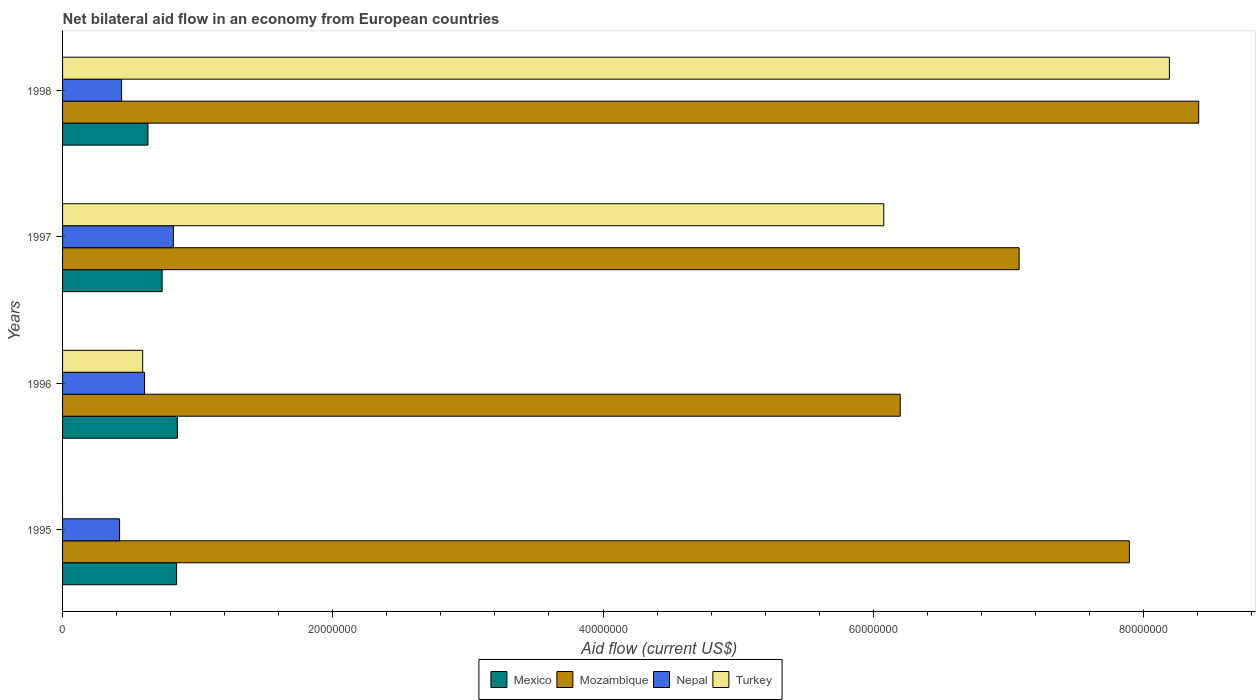Are the number of bars on each tick of the Y-axis equal?
Make the answer very short. No. How many bars are there on the 1st tick from the top?
Provide a succinct answer. 4. How many bars are there on the 4th tick from the bottom?
Make the answer very short. 4. What is the net bilateral aid flow in Mexico in 1995?
Offer a very short reply. 8.44e+06. Across all years, what is the maximum net bilateral aid flow in Mozambique?
Give a very brief answer. 8.41e+07. Across all years, what is the minimum net bilateral aid flow in Mozambique?
Your answer should be compact. 6.20e+07. In which year was the net bilateral aid flow in Mexico maximum?
Ensure brevity in your answer.  1996. What is the total net bilateral aid flow in Nepal in the graph?
Offer a very short reply. 2.29e+07. What is the difference between the net bilateral aid flow in Nepal in 1995 and that in 1997?
Provide a succinct answer. -3.98e+06. What is the average net bilateral aid flow in Turkey per year?
Ensure brevity in your answer.  3.72e+07. In the year 1997, what is the difference between the net bilateral aid flow in Mozambique and net bilateral aid flow in Mexico?
Ensure brevity in your answer.  6.34e+07. What is the ratio of the net bilateral aid flow in Mozambique in 1995 to that in 1998?
Your answer should be compact. 0.94. Is the net bilateral aid flow in Mexico in 1997 less than that in 1998?
Make the answer very short. No. Is the difference between the net bilateral aid flow in Mozambique in 1995 and 1997 greater than the difference between the net bilateral aid flow in Mexico in 1995 and 1997?
Give a very brief answer. Yes. What is the difference between the highest and the lowest net bilateral aid flow in Nepal?
Your response must be concise. 3.98e+06. In how many years, is the net bilateral aid flow in Nepal greater than the average net bilateral aid flow in Nepal taken over all years?
Offer a terse response. 2. Is it the case that in every year, the sum of the net bilateral aid flow in Mozambique and net bilateral aid flow in Nepal is greater than the net bilateral aid flow in Turkey?
Provide a succinct answer. Yes. Are all the bars in the graph horizontal?
Keep it short and to the point. Yes. How many years are there in the graph?
Offer a terse response. 4. What is the difference between two consecutive major ticks on the X-axis?
Give a very brief answer. 2.00e+07. Are the values on the major ticks of X-axis written in scientific E-notation?
Offer a very short reply. No. What is the title of the graph?
Offer a terse response. Net bilateral aid flow in an economy from European countries. Does "Australia" appear as one of the legend labels in the graph?
Make the answer very short. No. What is the label or title of the X-axis?
Give a very brief answer. Aid flow (current US$). What is the Aid flow (current US$) of Mexico in 1995?
Provide a succinct answer. 8.44e+06. What is the Aid flow (current US$) in Mozambique in 1995?
Your response must be concise. 7.90e+07. What is the Aid flow (current US$) in Nepal in 1995?
Offer a terse response. 4.22e+06. What is the Aid flow (current US$) in Mexico in 1996?
Your response must be concise. 8.50e+06. What is the Aid flow (current US$) of Mozambique in 1996?
Make the answer very short. 6.20e+07. What is the Aid flow (current US$) in Nepal in 1996?
Provide a short and direct response. 6.07e+06. What is the Aid flow (current US$) of Turkey in 1996?
Offer a terse response. 5.93e+06. What is the Aid flow (current US$) in Mexico in 1997?
Your answer should be compact. 7.37e+06. What is the Aid flow (current US$) of Mozambique in 1997?
Your answer should be very brief. 7.08e+07. What is the Aid flow (current US$) of Nepal in 1997?
Offer a terse response. 8.20e+06. What is the Aid flow (current US$) in Turkey in 1997?
Your response must be concise. 6.08e+07. What is the Aid flow (current US$) of Mexico in 1998?
Make the answer very short. 6.32e+06. What is the Aid flow (current US$) of Mozambique in 1998?
Your answer should be compact. 8.41e+07. What is the Aid flow (current US$) in Nepal in 1998?
Your answer should be compact. 4.37e+06. What is the Aid flow (current US$) in Turkey in 1998?
Provide a short and direct response. 8.19e+07. Across all years, what is the maximum Aid flow (current US$) of Mexico?
Offer a terse response. 8.50e+06. Across all years, what is the maximum Aid flow (current US$) in Mozambique?
Offer a terse response. 8.41e+07. Across all years, what is the maximum Aid flow (current US$) in Nepal?
Ensure brevity in your answer.  8.20e+06. Across all years, what is the maximum Aid flow (current US$) of Turkey?
Offer a terse response. 8.19e+07. Across all years, what is the minimum Aid flow (current US$) of Mexico?
Ensure brevity in your answer.  6.32e+06. Across all years, what is the minimum Aid flow (current US$) in Mozambique?
Your answer should be very brief. 6.20e+07. Across all years, what is the minimum Aid flow (current US$) of Nepal?
Offer a terse response. 4.22e+06. Across all years, what is the minimum Aid flow (current US$) of Turkey?
Your answer should be very brief. 0. What is the total Aid flow (current US$) of Mexico in the graph?
Provide a short and direct response. 3.06e+07. What is the total Aid flow (current US$) in Mozambique in the graph?
Offer a very short reply. 2.96e+08. What is the total Aid flow (current US$) in Nepal in the graph?
Ensure brevity in your answer.  2.29e+07. What is the total Aid flow (current US$) of Turkey in the graph?
Your answer should be very brief. 1.49e+08. What is the difference between the Aid flow (current US$) of Mexico in 1995 and that in 1996?
Provide a short and direct response. -6.00e+04. What is the difference between the Aid flow (current US$) in Mozambique in 1995 and that in 1996?
Your response must be concise. 1.70e+07. What is the difference between the Aid flow (current US$) of Nepal in 1995 and that in 1996?
Your response must be concise. -1.85e+06. What is the difference between the Aid flow (current US$) of Mexico in 1995 and that in 1997?
Your answer should be compact. 1.07e+06. What is the difference between the Aid flow (current US$) of Mozambique in 1995 and that in 1997?
Your response must be concise. 8.16e+06. What is the difference between the Aid flow (current US$) in Nepal in 1995 and that in 1997?
Your response must be concise. -3.98e+06. What is the difference between the Aid flow (current US$) of Mexico in 1995 and that in 1998?
Keep it short and to the point. 2.12e+06. What is the difference between the Aid flow (current US$) in Mozambique in 1995 and that in 1998?
Give a very brief answer. -5.13e+06. What is the difference between the Aid flow (current US$) of Nepal in 1995 and that in 1998?
Provide a short and direct response. -1.50e+05. What is the difference between the Aid flow (current US$) in Mexico in 1996 and that in 1997?
Offer a terse response. 1.13e+06. What is the difference between the Aid flow (current US$) of Mozambique in 1996 and that in 1997?
Make the answer very short. -8.80e+06. What is the difference between the Aid flow (current US$) in Nepal in 1996 and that in 1997?
Your answer should be compact. -2.13e+06. What is the difference between the Aid flow (current US$) in Turkey in 1996 and that in 1997?
Keep it short and to the point. -5.48e+07. What is the difference between the Aid flow (current US$) of Mexico in 1996 and that in 1998?
Your answer should be very brief. 2.18e+06. What is the difference between the Aid flow (current US$) in Mozambique in 1996 and that in 1998?
Your answer should be compact. -2.21e+07. What is the difference between the Aid flow (current US$) in Nepal in 1996 and that in 1998?
Ensure brevity in your answer.  1.70e+06. What is the difference between the Aid flow (current US$) of Turkey in 1996 and that in 1998?
Offer a very short reply. -7.60e+07. What is the difference between the Aid flow (current US$) in Mexico in 1997 and that in 1998?
Make the answer very short. 1.05e+06. What is the difference between the Aid flow (current US$) of Mozambique in 1997 and that in 1998?
Make the answer very short. -1.33e+07. What is the difference between the Aid flow (current US$) in Nepal in 1997 and that in 1998?
Offer a very short reply. 3.83e+06. What is the difference between the Aid flow (current US$) in Turkey in 1997 and that in 1998?
Provide a succinct answer. -2.11e+07. What is the difference between the Aid flow (current US$) of Mexico in 1995 and the Aid flow (current US$) of Mozambique in 1996?
Make the answer very short. -5.36e+07. What is the difference between the Aid flow (current US$) of Mexico in 1995 and the Aid flow (current US$) of Nepal in 1996?
Offer a terse response. 2.37e+06. What is the difference between the Aid flow (current US$) of Mexico in 1995 and the Aid flow (current US$) of Turkey in 1996?
Your answer should be compact. 2.51e+06. What is the difference between the Aid flow (current US$) of Mozambique in 1995 and the Aid flow (current US$) of Nepal in 1996?
Provide a succinct answer. 7.29e+07. What is the difference between the Aid flow (current US$) in Mozambique in 1995 and the Aid flow (current US$) in Turkey in 1996?
Ensure brevity in your answer.  7.30e+07. What is the difference between the Aid flow (current US$) in Nepal in 1995 and the Aid flow (current US$) in Turkey in 1996?
Ensure brevity in your answer.  -1.71e+06. What is the difference between the Aid flow (current US$) of Mexico in 1995 and the Aid flow (current US$) of Mozambique in 1997?
Offer a terse response. -6.24e+07. What is the difference between the Aid flow (current US$) in Mexico in 1995 and the Aid flow (current US$) in Turkey in 1997?
Your answer should be very brief. -5.23e+07. What is the difference between the Aid flow (current US$) of Mozambique in 1995 and the Aid flow (current US$) of Nepal in 1997?
Keep it short and to the point. 7.08e+07. What is the difference between the Aid flow (current US$) in Mozambique in 1995 and the Aid flow (current US$) in Turkey in 1997?
Ensure brevity in your answer.  1.82e+07. What is the difference between the Aid flow (current US$) in Nepal in 1995 and the Aid flow (current US$) in Turkey in 1997?
Provide a succinct answer. -5.66e+07. What is the difference between the Aid flow (current US$) of Mexico in 1995 and the Aid flow (current US$) of Mozambique in 1998?
Offer a terse response. -7.56e+07. What is the difference between the Aid flow (current US$) in Mexico in 1995 and the Aid flow (current US$) in Nepal in 1998?
Offer a terse response. 4.07e+06. What is the difference between the Aid flow (current US$) in Mexico in 1995 and the Aid flow (current US$) in Turkey in 1998?
Keep it short and to the point. -7.35e+07. What is the difference between the Aid flow (current US$) of Mozambique in 1995 and the Aid flow (current US$) of Nepal in 1998?
Provide a short and direct response. 7.46e+07. What is the difference between the Aid flow (current US$) of Mozambique in 1995 and the Aid flow (current US$) of Turkey in 1998?
Offer a very short reply. -2.96e+06. What is the difference between the Aid flow (current US$) of Nepal in 1995 and the Aid flow (current US$) of Turkey in 1998?
Make the answer very short. -7.77e+07. What is the difference between the Aid flow (current US$) of Mexico in 1996 and the Aid flow (current US$) of Mozambique in 1997?
Your answer should be very brief. -6.23e+07. What is the difference between the Aid flow (current US$) of Mexico in 1996 and the Aid flow (current US$) of Nepal in 1997?
Provide a short and direct response. 3.00e+05. What is the difference between the Aid flow (current US$) in Mexico in 1996 and the Aid flow (current US$) in Turkey in 1997?
Provide a succinct answer. -5.23e+07. What is the difference between the Aid flow (current US$) of Mozambique in 1996 and the Aid flow (current US$) of Nepal in 1997?
Offer a very short reply. 5.38e+07. What is the difference between the Aid flow (current US$) of Mozambique in 1996 and the Aid flow (current US$) of Turkey in 1997?
Give a very brief answer. 1.22e+06. What is the difference between the Aid flow (current US$) of Nepal in 1996 and the Aid flow (current US$) of Turkey in 1997?
Offer a very short reply. -5.47e+07. What is the difference between the Aid flow (current US$) in Mexico in 1996 and the Aid flow (current US$) in Mozambique in 1998?
Provide a succinct answer. -7.56e+07. What is the difference between the Aid flow (current US$) in Mexico in 1996 and the Aid flow (current US$) in Nepal in 1998?
Offer a terse response. 4.13e+06. What is the difference between the Aid flow (current US$) in Mexico in 1996 and the Aid flow (current US$) in Turkey in 1998?
Your response must be concise. -7.34e+07. What is the difference between the Aid flow (current US$) in Mozambique in 1996 and the Aid flow (current US$) in Nepal in 1998?
Keep it short and to the point. 5.76e+07. What is the difference between the Aid flow (current US$) of Mozambique in 1996 and the Aid flow (current US$) of Turkey in 1998?
Give a very brief answer. -1.99e+07. What is the difference between the Aid flow (current US$) in Nepal in 1996 and the Aid flow (current US$) in Turkey in 1998?
Your response must be concise. -7.58e+07. What is the difference between the Aid flow (current US$) of Mexico in 1997 and the Aid flow (current US$) of Mozambique in 1998?
Offer a very short reply. -7.67e+07. What is the difference between the Aid flow (current US$) of Mexico in 1997 and the Aid flow (current US$) of Turkey in 1998?
Keep it short and to the point. -7.46e+07. What is the difference between the Aid flow (current US$) of Mozambique in 1997 and the Aid flow (current US$) of Nepal in 1998?
Give a very brief answer. 6.64e+07. What is the difference between the Aid flow (current US$) of Mozambique in 1997 and the Aid flow (current US$) of Turkey in 1998?
Make the answer very short. -1.11e+07. What is the difference between the Aid flow (current US$) of Nepal in 1997 and the Aid flow (current US$) of Turkey in 1998?
Provide a short and direct response. -7.37e+07. What is the average Aid flow (current US$) in Mexico per year?
Keep it short and to the point. 7.66e+06. What is the average Aid flow (current US$) of Mozambique per year?
Your response must be concise. 7.40e+07. What is the average Aid flow (current US$) in Nepal per year?
Ensure brevity in your answer.  5.72e+06. What is the average Aid flow (current US$) of Turkey per year?
Provide a short and direct response. 3.72e+07. In the year 1995, what is the difference between the Aid flow (current US$) of Mexico and Aid flow (current US$) of Mozambique?
Provide a succinct answer. -7.05e+07. In the year 1995, what is the difference between the Aid flow (current US$) of Mexico and Aid flow (current US$) of Nepal?
Your answer should be compact. 4.22e+06. In the year 1995, what is the difference between the Aid flow (current US$) in Mozambique and Aid flow (current US$) in Nepal?
Provide a short and direct response. 7.47e+07. In the year 1996, what is the difference between the Aid flow (current US$) of Mexico and Aid flow (current US$) of Mozambique?
Your answer should be compact. -5.35e+07. In the year 1996, what is the difference between the Aid flow (current US$) in Mexico and Aid flow (current US$) in Nepal?
Your answer should be very brief. 2.43e+06. In the year 1996, what is the difference between the Aid flow (current US$) in Mexico and Aid flow (current US$) in Turkey?
Keep it short and to the point. 2.57e+06. In the year 1996, what is the difference between the Aid flow (current US$) of Mozambique and Aid flow (current US$) of Nepal?
Provide a short and direct response. 5.59e+07. In the year 1996, what is the difference between the Aid flow (current US$) of Mozambique and Aid flow (current US$) of Turkey?
Offer a terse response. 5.61e+07. In the year 1996, what is the difference between the Aid flow (current US$) of Nepal and Aid flow (current US$) of Turkey?
Your response must be concise. 1.40e+05. In the year 1997, what is the difference between the Aid flow (current US$) in Mexico and Aid flow (current US$) in Mozambique?
Your response must be concise. -6.34e+07. In the year 1997, what is the difference between the Aid flow (current US$) in Mexico and Aid flow (current US$) in Nepal?
Provide a succinct answer. -8.30e+05. In the year 1997, what is the difference between the Aid flow (current US$) in Mexico and Aid flow (current US$) in Turkey?
Give a very brief answer. -5.34e+07. In the year 1997, what is the difference between the Aid flow (current US$) in Mozambique and Aid flow (current US$) in Nepal?
Offer a terse response. 6.26e+07. In the year 1997, what is the difference between the Aid flow (current US$) in Mozambique and Aid flow (current US$) in Turkey?
Give a very brief answer. 1.00e+07. In the year 1997, what is the difference between the Aid flow (current US$) of Nepal and Aid flow (current US$) of Turkey?
Your answer should be compact. -5.26e+07. In the year 1998, what is the difference between the Aid flow (current US$) in Mexico and Aid flow (current US$) in Mozambique?
Give a very brief answer. -7.78e+07. In the year 1998, what is the difference between the Aid flow (current US$) in Mexico and Aid flow (current US$) in Nepal?
Provide a short and direct response. 1.95e+06. In the year 1998, what is the difference between the Aid flow (current US$) in Mexico and Aid flow (current US$) in Turkey?
Make the answer very short. -7.56e+07. In the year 1998, what is the difference between the Aid flow (current US$) in Mozambique and Aid flow (current US$) in Nepal?
Ensure brevity in your answer.  7.97e+07. In the year 1998, what is the difference between the Aid flow (current US$) of Mozambique and Aid flow (current US$) of Turkey?
Offer a very short reply. 2.17e+06. In the year 1998, what is the difference between the Aid flow (current US$) of Nepal and Aid flow (current US$) of Turkey?
Your response must be concise. -7.76e+07. What is the ratio of the Aid flow (current US$) in Mexico in 1995 to that in 1996?
Your answer should be very brief. 0.99. What is the ratio of the Aid flow (current US$) of Mozambique in 1995 to that in 1996?
Provide a short and direct response. 1.27. What is the ratio of the Aid flow (current US$) of Nepal in 1995 to that in 1996?
Make the answer very short. 0.7. What is the ratio of the Aid flow (current US$) in Mexico in 1995 to that in 1997?
Make the answer very short. 1.15. What is the ratio of the Aid flow (current US$) in Mozambique in 1995 to that in 1997?
Make the answer very short. 1.12. What is the ratio of the Aid flow (current US$) of Nepal in 1995 to that in 1997?
Your answer should be compact. 0.51. What is the ratio of the Aid flow (current US$) in Mexico in 1995 to that in 1998?
Your response must be concise. 1.34. What is the ratio of the Aid flow (current US$) of Mozambique in 1995 to that in 1998?
Your answer should be compact. 0.94. What is the ratio of the Aid flow (current US$) of Nepal in 1995 to that in 1998?
Make the answer very short. 0.97. What is the ratio of the Aid flow (current US$) in Mexico in 1996 to that in 1997?
Make the answer very short. 1.15. What is the ratio of the Aid flow (current US$) of Mozambique in 1996 to that in 1997?
Give a very brief answer. 0.88. What is the ratio of the Aid flow (current US$) in Nepal in 1996 to that in 1997?
Your answer should be compact. 0.74. What is the ratio of the Aid flow (current US$) in Turkey in 1996 to that in 1997?
Ensure brevity in your answer.  0.1. What is the ratio of the Aid flow (current US$) in Mexico in 1996 to that in 1998?
Your response must be concise. 1.34. What is the ratio of the Aid flow (current US$) in Mozambique in 1996 to that in 1998?
Your response must be concise. 0.74. What is the ratio of the Aid flow (current US$) of Nepal in 1996 to that in 1998?
Offer a terse response. 1.39. What is the ratio of the Aid flow (current US$) of Turkey in 1996 to that in 1998?
Offer a very short reply. 0.07. What is the ratio of the Aid flow (current US$) of Mexico in 1997 to that in 1998?
Make the answer very short. 1.17. What is the ratio of the Aid flow (current US$) of Mozambique in 1997 to that in 1998?
Offer a very short reply. 0.84. What is the ratio of the Aid flow (current US$) in Nepal in 1997 to that in 1998?
Your response must be concise. 1.88. What is the ratio of the Aid flow (current US$) of Turkey in 1997 to that in 1998?
Make the answer very short. 0.74. What is the difference between the highest and the second highest Aid flow (current US$) of Mexico?
Provide a succinct answer. 6.00e+04. What is the difference between the highest and the second highest Aid flow (current US$) of Mozambique?
Provide a short and direct response. 5.13e+06. What is the difference between the highest and the second highest Aid flow (current US$) in Nepal?
Make the answer very short. 2.13e+06. What is the difference between the highest and the second highest Aid flow (current US$) in Turkey?
Provide a succinct answer. 2.11e+07. What is the difference between the highest and the lowest Aid flow (current US$) in Mexico?
Give a very brief answer. 2.18e+06. What is the difference between the highest and the lowest Aid flow (current US$) of Mozambique?
Keep it short and to the point. 2.21e+07. What is the difference between the highest and the lowest Aid flow (current US$) of Nepal?
Provide a short and direct response. 3.98e+06. What is the difference between the highest and the lowest Aid flow (current US$) of Turkey?
Offer a very short reply. 8.19e+07. 